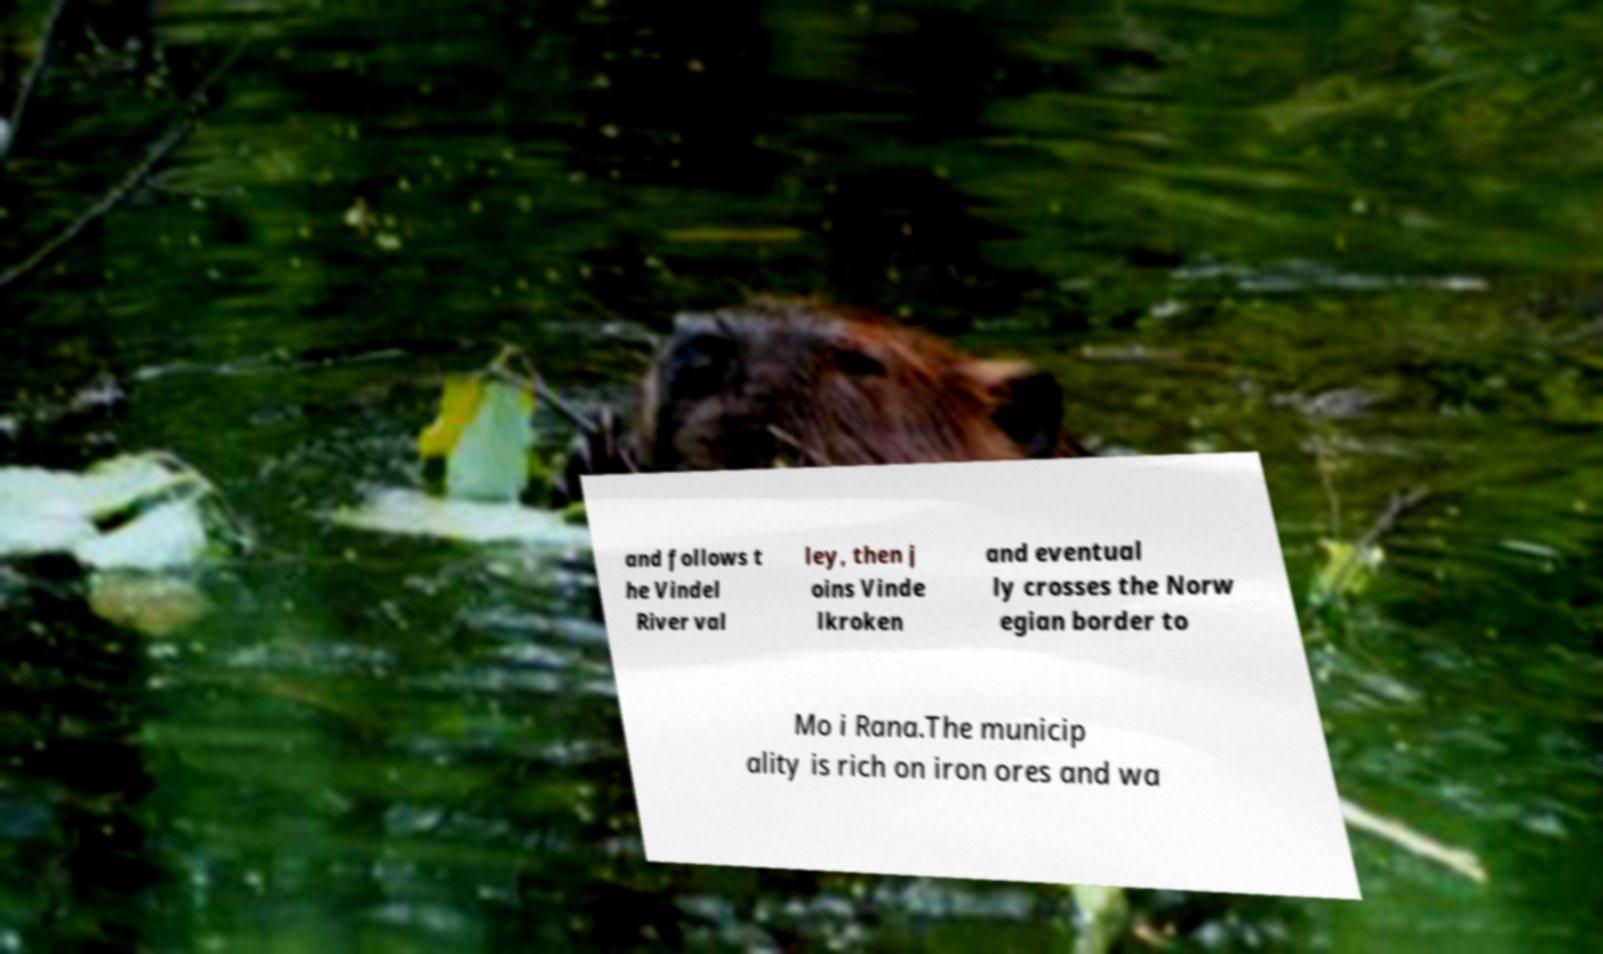Could you assist in decoding the text presented in this image and type it out clearly? and follows t he Vindel River val ley, then j oins Vinde lkroken and eventual ly crosses the Norw egian border to Mo i Rana.The municip ality is rich on iron ores and wa 